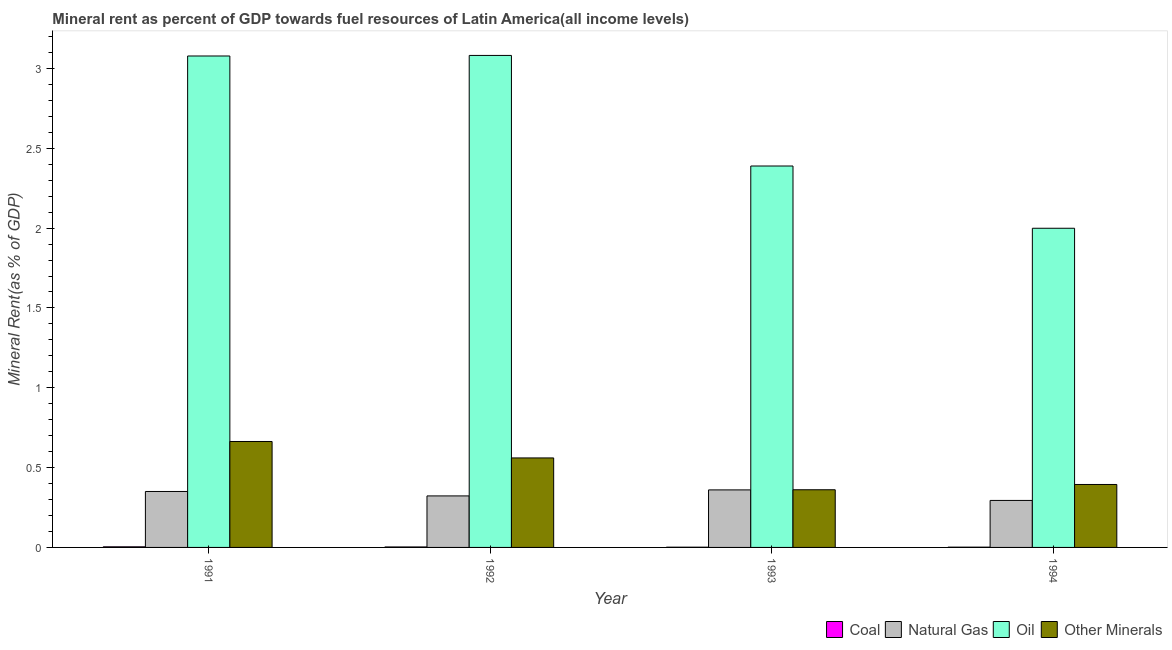How many different coloured bars are there?
Provide a short and direct response. 4. Are the number of bars per tick equal to the number of legend labels?
Offer a terse response. Yes. Are the number of bars on each tick of the X-axis equal?
Provide a succinct answer. Yes. How many bars are there on the 3rd tick from the left?
Your response must be concise. 4. What is the label of the 4th group of bars from the left?
Keep it short and to the point. 1994. In how many cases, is the number of bars for a given year not equal to the number of legend labels?
Your answer should be compact. 0. What is the natural gas rent in 1991?
Keep it short and to the point. 0.35. Across all years, what is the maximum  rent of other minerals?
Your response must be concise. 0.66. Across all years, what is the minimum natural gas rent?
Give a very brief answer. 0.29. In which year was the natural gas rent maximum?
Your answer should be very brief. 1993. What is the total natural gas rent in the graph?
Your response must be concise. 1.33. What is the difference between the  rent of other minerals in 1991 and that in 1993?
Your answer should be very brief. 0.3. What is the difference between the  rent of other minerals in 1991 and the natural gas rent in 1994?
Give a very brief answer. 0.27. What is the average  rent of other minerals per year?
Provide a short and direct response. 0.49. In the year 1992, what is the difference between the coal rent and natural gas rent?
Ensure brevity in your answer.  0. In how many years, is the  rent of other minerals greater than 3 %?
Give a very brief answer. 0. What is the ratio of the natural gas rent in 1992 to that in 1993?
Ensure brevity in your answer.  0.9. What is the difference between the highest and the second highest natural gas rent?
Keep it short and to the point. 0.01. What is the difference between the highest and the lowest natural gas rent?
Your response must be concise. 0.07. In how many years, is the  rent of other minerals greater than the average  rent of other minerals taken over all years?
Make the answer very short. 2. Is the sum of the coal rent in 1991 and 1992 greater than the maximum  rent of other minerals across all years?
Provide a succinct answer. Yes. Is it the case that in every year, the sum of the  rent of other minerals and oil rent is greater than the sum of coal rent and natural gas rent?
Give a very brief answer. Yes. What does the 4th bar from the left in 1991 represents?
Offer a terse response. Other Minerals. What does the 2nd bar from the right in 1993 represents?
Your answer should be very brief. Oil. Are all the bars in the graph horizontal?
Provide a succinct answer. No. Are the values on the major ticks of Y-axis written in scientific E-notation?
Your answer should be compact. No. Does the graph contain grids?
Your response must be concise. No. Where does the legend appear in the graph?
Your answer should be compact. Bottom right. How are the legend labels stacked?
Give a very brief answer. Horizontal. What is the title of the graph?
Your response must be concise. Mineral rent as percent of GDP towards fuel resources of Latin America(all income levels). What is the label or title of the Y-axis?
Provide a succinct answer. Mineral Rent(as % of GDP). What is the Mineral Rent(as % of GDP) in Coal in 1991?
Provide a short and direct response. 0. What is the Mineral Rent(as % of GDP) in Natural Gas in 1991?
Your answer should be very brief. 0.35. What is the Mineral Rent(as % of GDP) of Oil in 1991?
Offer a terse response. 3.08. What is the Mineral Rent(as % of GDP) of Other Minerals in 1991?
Offer a terse response. 0.66. What is the Mineral Rent(as % of GDP) in Coal in 1992?
Make the answer very short. 0. What is the Mineral Rent(as % of GDP) in Natural Gas in 1992?
Your answer should be compact. 0.32. What is the Mineral Rent(as % of GDP) of Oil in 1992?
Your answer should be compact. 3.08. What is the Mineral Rent(as % of GDP) in Other Minerals in 1992?
Your answer should be compact. 0.56. What is the Mineral Rent(as % of GDP) in Coal in 1993?
Offer a very short reply. 0. What is the Mineral Rent(as % of GDP) in Natural Gas in 1993?
Provide a short and direct response. 0.36. What is the Mineral Rent(as % of GDP) in Oil in 1993?
Your answer should be very brief. 2.39. What is the Mineral Rent(as % of GDP) in Other Minerals in 1993?
Provide a short and direct response. 0.36. What is the Mineral Rent(as % of GDP) in Coal in 1994?
Provide a short and direct response. 0. What is the Mineral Rent(as % of GDP) in Natural Gas in 1994?
Your answer should be very brief. 0.29. What is the Mineral Rent(as % of GDP) of Oil in 1994?
Keep it short and to the point. 2. What is the Mineral Rent(as % of GDP) in Other Minerals in 1994?
Keep it short and to the point. 0.39. Across all years, what is the maximum Mineral Rent(as % of GDP) of Coal?
Provide a succinct answer. 0. Across all years, what is the maximum Mineral Rent(as % of GDP) in Natural Gas?
Your answer should be compact. 0.36. Across all years, what is the maximum Mineral Rent(as % of GDP) in Oil?
Your answer should be very brief. 3.08. Across all years, what is the maximum Mineral Rent(as % of GDP) of Other Minerals?
Give a very brief answer. 0.66. Across all years, what is the minimum Mineral Rent(as % of GDP) in Coal?
Provide a short and direct response. 0. Across all years, what is the minimum Mineral Rent(as % of GDP) of Natural Gas?
Keep it short and to the point. 0.29. Across all years, what is the minimum Mineral Rent(as % of GDP) of Oil?
Your answer should be very brief. 2. Across all years, what is the minimum Mineral Rent(as % of GDP) of Other Minerals?
Give a very brief answer. 0.36. What is the total Mineral Rent(as % of GDP) in Coal in the graph?
Provide a short and direct response. 0.01. What is the total Mineral Rent(as % of GDP) of Natural Gas in the graph?
Make the answer very short. 1.33. What is the total Mineral Rent(as % of GDP) in Oil in the graph?
Offer a terse response. 10.55. What is the total Mineral Rent(as % of GDP) in Other Minerals in the graph?
Keep it short and to the point. 1.98. What is the difference between the Mineral Rent(as % of GDP) of Coal in 1991 and that in 1992?
Ensure brevity in your answer.  0. What is the difference between the Mineral Rent(as % of GDP) of Natural Gas in 1991 and that in 1992?
Provide a short and direct response. 0.03. What is the difference between the Mineral Rent(as % of GDP) in Oil in 1991 and that in 1992?
Your answer should be compact. -0. What is the difference between the Mineral Rent(as % of GDP) in Other Minerals in 1991 and that in 1992?
Offer a very short reply. 0.1. What is the difference between the Mineral Rent(as % of GDP) of Coal in 1991 and that in 1993?
Provide a short and direct response. 0. What is the difference between the Mineral Rent(as % of GDP) in Natural Gas in 1991 and that in 1993?
Offer a very short reply. -0.01. What is the difference between the Mineral Rent(as % of GDP) in Oil in 1991 and that in 1993?
Provide a succinct answer. 0.69. What is the difference between the Mineral Rent(as % of GDP) in Other Minerals in 1991 and that in 1993?
Offer a terse response. 0.3. What is the difference between the Mineral Rent(as % of GDP) in Coal in 1991 and that in 1994?
Offer a terse response. 0. What is the difference between the Mineral Rent(as % of GDP) in Natural Gas in 1991 and that in 1994?
Ensure brevity in your answer.  0.06. What is the difference between the Mineral Rent(as % of GDP) in Oil in 1991 and that in 1994?
Provide a short and direct response. 1.08. What is the difference between the Mineral Rent(as % of GDP) of Other Minerals in 1991 and that in 1994?
Make the answer very short. 0.27. What is the difference between the Mineral Rent(as % of GDP) in Coal in 1992 and that in 1993?
Offer a terse response. 0. What is the difference between the Mineral Rent(as % of GDP) of Natural Gas in 1992 and that in 1993?
Ensure brevity in your answer.  -0.04. What is the difference between the Mineral Rent(as % of GDP) of Oil in 1992 and that in 1993?
Keep it short and to the point. 0.69. What is the difference between the Mineral Rent(as % of GDP) in Other Minerals in 1992 and that in 1993?
Give a very brief answer. 0.2. What is the difference between the Mineral Rent(as % of GDP) of Coal in 1992 and that in 1994?
Offer a very short reply. 0. What is the difference between the Mineral Rent(as % of GDP) in Natural Gas in 1992 and that in 1994?
Offer a very short reply. 0.03. What is the difference between the Mineral Rent(as % of GDP) in Oil in 1992 and that in 1994?
Ensure brevity in your answer.  1.08. What is the difference between the Mineral Rent(as % of GDP) of Other Minerals in 1992 and that in 1994?
Keep it short and to the point. 0.17. What is the difference between the Mineral Rent(as % of GDP) of Coal in 1993 and that in 1994?
Your response must be concise. -0. What is the difference between the Mineral Rent(as % of GDP) of Natural Gas in 1993 and that in 1994?
Give a very brief answer. 0.07. What is the difference between the Mineral Rent(as % of GDP) of Oil in 1993 and that in 1994?
Provide a succinct answer. 0.39. What is the difference between the Mineral Rent(as % of GDP) of Other Minerals in 1993 and that in 1994?
Your response must be concise. -0.03. What is the difference between the Mineral Rent(as % of GDP) of Coal in 1991 and the Mineral Rent(as % of GDP) of Natural Gas in 1992?
Your answer should be very brief. -0.32. What is the difference between the Mineral Rent(as % of GDP) in Coal in 1991 and the Mineral Rent(as % of GDP) in Oil in 1992?
Provide a succinct answer. -3.08. What is the difference between the Mineral Rent(as % of GDP) in Coal in 1991 and the Mineral Rent(as % of GDP) in Other Minerals in 1992?
Ensure brevity in your answer.  -0.56. What is the difference between the Mineral Rent(as % of GDP) of Natural Gas in 1991 and the Mineral Rent(as % of GDP) of Oil in 1992?
Provide a succinct answer. -2.73. What is the difference between the Mineral Rent(as % of GDP) of Natural Gas in 1991 and the Mineral Rent(as % of GDP) of Other Minerals in 1992?
Ensure brevity in your answer.  -0.21. What is the difference between the Mineral Rent(as % of GDP) of Oil in 1991 and the Mineral Rent(as % of GDP) of Other Minerals in 1992?
Give a very brief answer. 2.52. What is the difference between the Mineral Rent(as % of GDP) of Coal in 1991 and the Mineral Rent(as % of GDP) of Natural Gas in 1993?
Your answer should be compact. -0.36. What is the difference between the Mineral Rent(as % of GDP) of Coal in 1991 and the Mineral Rent(as % of GDP) of Oil in 1993?
Your answer should be very brief. -2.39. What is the difference between the Mineral Rent(as % of GDP) in Coal in 1991 and the Mineral Rent(as % of GDP) in Other Minerals in 1993?
Provide a succinct answer. -0.36. What is the difference between the Mineral Rent(as % of GDP) in Natural Gas in 1991 and the Mineral Rent(as % of GDP) in Oil in 1993?
Your answer should be very brief. -2.04. What is the difference between the Mineral Rent(as % of GDP) of Natural Gas in 1991 and the Mineral Rent(as % of GDP) of Other Minerals in 1993?
Your response must be concise. -0.01. What is the difference between the Mineral Rent(as % of GDP) of Oil in 1991 and the Mineral Rent(as % of GDP) of Other Minerals in 1993?
Ensure brevity in your answer.  2.72. What is the difference between the Mineral Rent(as % of GDP) in Coal in 1991 and the Mineral Rent(as % of GDP) in Natural Gas in 1994?
Your response must be concise. -0.29. What is the difference between the Mineral Rent(as % of GDP) in Coal in 1991 and the Mineral Rent(as % of GDP) in Oil in 1994?
Provide a succinct answer. -2. What is the difference between the Mineral Rent(as % of GDP) in Coal in 1991 and the Mineral Rent(as % of GDP) in Other Minerals in 1994?
Keep it short and to the point. -0.39. What is the difference between the Mineral Rent(as % of GDP) in Natural Gas in 1991 and the Mineral Rent(as % of GDP) in Oil in 1994?
Offer a very short reply. -1.65. What is the difference between the Mineral Rent(as % of GDP) of Natural Gas in 1991 and the Mineral Rent(as % of GDP) of Other Minerals in 1994?
Your response must be concise. -0.04. What is the difference between the Mineral Rent(as % of GDP) of Oil in 1991 and the Mineral Rent(as % of GDP) of Other Minerals in 1994?
Offer a very short reply. 2.68. What is the difference between the Mineral Rent(as % of GDP) of Coal in 1992 and the Mineral Rent(as % of GDP) of Natural Gas in 1993?
Offer a very short reply. -0.36. What is the difference between the Mineral Rent(as % of GDP) of Coal in 1992 and the Mineral Rent(as % of GDP) of Oil in 1993?
Provide a succinct answer. -2.39. What is the difference between the Mineral Rent(as % of GDP) in Coal in 1992 and the Mineral Rent(as % of GDP) in Other Minerals in 1993?
Make the answer very short. -0.36. What is the difference between the Mineral Rent(as % of GDP) of Natural Gas in 1992 and the Mineral Rent(as % of GDP) of Oil in 1993?
Keep it short and to the point. -2.07. What is the difference between the Mineral Rent(as % of GDP) in Natural Gas in 1992 and the Mineral Rent(as % of GDP) in Other Minerals in 1993?
Keep it short and to the point. -0.04. What is the difference between the Mineral Rent(as % of GDP) of Oil in 1992 and the Mineral Rent(as % of GDP) of Other Minerals in 1993?
Ensure brevity in your answer.  2.72. What is the difference between the Mineral Rent(as % of GDP) of Coal in 1992 and the Mineral Rent(as % of GDP) of Natural Gas in 1994?
Your response must be concise. -0.29. What is the difference between the Mineral Rent(as % of GDP) of Coal in 1992 and the Mineral Rent(as % of GDP) of Oil in 1994?
Provide a short and direct response. -2. What is the difference between the Mineral Rent(as % of GDP) in Coal in 1992 and the Mineral Rent(as % of GDP) in Other Minerals in 1994?
Offer a very short reply. -0.39. What is the difference between the Mineral Rent(as % of GDP) in Natural Gas in 1992 and the Mineral Rent(as % of GDP) in Oil in 1994?
Make the answer very short. -1.68. What is the difference between the Mineral Rent(as % of GDP) in Natural Gas in 1992 and the Mineral Rent(as % of GDP) in Other Minerals in 1994?
Provide a short and direct response. -0.07. What is the difference between the Mineral Rent(as % of GDP) in Oil in 1992 and the Mineral Rent(as % of GDP) in Other Minerals in 1994?
Provide a succinct answer. 2.69. What is the difference between the Mineral Rent(as % of GDP) of Coal in 1993 and the Mineral Rent(as % of GDP) of Natural Gas in 1994?
Provide a short and direct response. -0.29. What is the difference between the Mineral Rent(as % of GDP) in Coal in 1993 and the Mineral Rent(as % of GDP) in Oil in 1994?
Give a very brief answer. -2. What is the difference between the Mineral Rent(as % of GDP) in Coal in 1993 and the Mineral Rent(as % of GDP) in Other Minerals in 1994?
Provide a succinct answer. -0.39. What is the difference between the Mineral Rent(as % of GDP) of Natural Gas in 1993 and the Mineral Rent(as % of GDP) of Oil in 1994?
Keep it short and to the point. -1.64. What is the difference between the Mineral Rent(as % of GDP) in Natural Gas in 1993 and the Mineral Rent(as % of GDP) in Other Minerals in 1994?
Ensure brevity in your answer.  -0.03. What is the difference between the Mineral Rent(as % of GDP) in Oil in 1993 and the Mineral Rent(as % of GDP) in Other Minerals in 1994?
Give a very brief answer. 1.99. What is the average Mineral Rent(as % of GDP) in Coal per year?
Make the answer very short. 0. What is the average Mineral Rent(as % of GDP) in Natural Gas per year?
Make the answer very short. 0.33. What is the average Mineral Rent(as % of GDP) of Oil per year?
Make the answer very short. 2.64. What is the average Mineral Rent(as % of GDP) of Other Minerals per year?
Offer a terse response. 0.49. In the year 1991, what is the difference between the Mineral Rent(as % of GDP) of Coal and Mineral Rent(as % of GDP) of Natural Gas?
Ensure brevity in your answer.  -0.35. In the year 1991, what is the difference between the Mineral Rent(as % of GDP) of Coal and Mineral Rent(as % of GDP) of Oil?
Your answer should be compact. -3.07. In the year 1991, what is the difference between the Mineral Rent(as % of GDP) in Coal and Mineral Rent(as % of GDP) in Other Minerals?
Offer a very short reply. -0.66. In the year 1991, what is the difference between the Mineral Rent(as % of GDP) of Natural Gas and Mineral Rent(as % of GDP) of Oil?
Offer a terse response. -2.73. In the year 1991, what is the difference between the Mineral Rent(as % of GDP) in Natural Gas and Mineral Rent(as % of GDP) in Other Minerals?
Make the answer very short. -0.31. In the year 1991, what is the difference between the Mineral Rent(as % of GDP) of Oil and Mineral Rent(as % of GDP) of Other Minerals?
Your response must be concise. 2.41. In the year 1992, what is the difference between the Mineral Rent(as % of GDP) of Coal and Mineral Rent(as % of GDP) of Natural Gas?
Offer a terse response. -0.32. In the year 1992, what is the difference between the Mineral Rent(as % of GDP) of Coal and Mineral Rent(as % of GDP) of Oil?
Keep it short and to the point. -3.08. In the year 1992, what is the difference between the Mineral Rent(as % of GDP) in Coal and Mineral Rent(as % of GDP) in Other Minerals?
Your answer should be compact. -0.56. In the year 1992, what is the difference between the Mineral Rent(as % of GDP) in Natural Gas and Mineral Rent(as % of GDP) in Oil?
Make the answer very short. -2.76. In the year 1992, what is the difference between the Mineral Rent(as % of GDP) of Natural Gas and Mineral Rent(as % of GDP) of Other Minerals?
Your answer should be very brief. -0.24. In the year 1992, what is the difference between the Mineral Rent(as % of GDP) in Oil and Mineral Rent(as % of GDP) in Other Minerals?
Provide a succinct answer. 2.52. In the year 1993, what is the difference between the Mineral Rent(as % of GDP) of Coal and Mineral Rent(as % of GDP) of Natural Gas?
Keep it short and to the point. -0.36. In the year 1993, what is the difference between the Mineral Rent(as % of GDP) of Coal and Mineral Rent(as % of GDP) of Oil?
Provide a short and direct response. -2.39. In the year 1993, what is the difference between the Mineral Rent(as % of GDP) in Coal and Mineral Rent(as % of GDP) in Other Minerals?
Offer a terse response. -0.36. In the year 1993, what is the difference between the Mineral Rent(as % of GDP) in Natural Gas and Mineral Rent(as % of GDP) in Oil?
Your response must be concise. -2.03. In the year 1993, what is the difference between the Mineral Rent(as % of GDP) in Natural Gas and Mineral Rent(as % of GDP) in Other Minerals?
Offer a terse response. -0. In the year 1993, what is the difference between the Mineral Rent(as % of GDP) of Oil and Mineral Rent(as % of GDP) of Other Minerals?
Offer a terse response. 2.03. In the year 1994, what is the difference between the Mineral Rent(as % of GDP) of Coal and Mineral Rent(as % of GDP) of Natural Gas?
Give a very brief answer. -0.29. In the year 1994, what is the difference between the Mineral Rent(as % of GDP) of Coal and Mineral Rent(as % of GDP) of Oil?
Ensure brevity in your answer.  -2. In the year 1994, what is the difference between the Mineral Rent(as % of GDP) in Coal and Mineral Rent(as % of GDP) in Other Minerals?
Keep it short and to the point. -0.39. In the year 1994, what is the difference between the Mineral Rent(as % of GDP) in Natural Gas and Mineral Rent(as % of GDP) in Oil?
Make the answer very short. -1.7. In the year 1994, what is the difference between the Mineral Rent(as % of GDP) in Natural Gas and Mineral Rent(as % of GDP) in Other Minerals?
Offer a terse response. -0.1. In the year 1994, what is the difference between the Mineral Rent(as % of GDP) in Oil and Mineral Rent(as % of GDP) in Other Minerals?
Make the answer very short. 1.6. What is the ratio of the Mineral Rent(as % of GDP) of Coal in 1991 to that in 1992?
Give a very brief answer. 1.29. What is the ratio of the Mineral Rent(as % of GDP) in Natural Gas in 1991 to that in 1992?
Offer a terse response. 1.09. What is the ratio of the Mineral Rent(as % of GDP) of Oil in 1991 to that in 1992?
Your answer should be compact. 1. What is the ratio of the Mineral Rent(as % of GDP) in Other Minerals in 1991 to that in 1992?
Give a very brief answer. 1.18. What is the ratio of the Mineral Rent(as % of GDP) in Coal in 1991 to that in 1993?
Provide a succinct answer. 2.55. What is the ratio of the Mineral Rent(as % of GDP) of Natural Gas in 1991 to that in 1993?
Offer a terse response. 0.97. What is the ratio of the Mineral Rent(as % of GDP) of Oil in 1991 to that in 1993?
Make the answer very short. 1.29. What is the ratio of the Mineral Rent(as % of GDP) in Other Minerals in 1991 to that in 1993?
Ensure brevity in your answer.  1.84. What is the ratio of the Mineral Rent(as % of GDP) in Coal in 1991 to that in 1994?
Offer a very short reply. 2.34. What is the ratio of the Mineral Rent(as % of GDP) of Natural Gas in 1991 to that in 1994?
Offer a terse response. 1.19. What is the ratio of the Mineral Rent(as % of GDP) in Oil in 1991 to that in 1994?
Give a very brief answer. 1.54. What is the ratio of the Mineral Rent(as % of GDP) in Other Minerals in 1991 to that in 1994?
Make the answer very short. 1.68. What is the ratio of the Mineral Rent(as % of GDP) in Coal in 1992 to that in 1993?
Offer a terse response. 1.98. What is the ratio of the Mineral Rent(as % of GDP) of Natural Gas in 1992 to that in 1993?
Your answer should be compact. 0.9. What is the ratio of the Mineral Rent(as % of GDP) in Oil in 1992 to that in 1993?
Ensure brevity in your answer.  1.29. What is the ratio of the Mineral Rent(as % of GDP) in Other Minerals in 1992 to that in 1993?
Your answer should be very brief. 1.55. What is the ratio of the Mineral Rent(as % of GDP) in Coal in 1992 to that in 1994?
Offer a terse response. 1.81. What is the ratio of the Mineral Rent(as % of GDP) in Natural Gas in 1992 to that in 1994?
Make the answer very short. 1.1. What is the ratio of the Mineral Rent(as % of GDP) in Oil in 1992 to that in 1994?
Provide a short and direct response. 1.54. What is the ratio of the Mineral Rent(as % of GDP) of Other Minerals in 1992 to that in 1994?
Your response must be concise. 1.42. What is the ratio of the Mineral Rent(as % of GDP) in Coal in 1993 to that in 1994?
Your answer should be very brief. 0.92. What is the ratio of the Mineral Rent(as % of GDP) of Natural Gas in 1993 to that in 1994?
Ensure brevity in your answer.  1.22. What is the ratio of the Mineral Rent(as % of GDP) of Oil in 1993 to that in 1994?
Offer a terse response. 1.2. What is the ratio of the Mineral Rent(as % of GDP) of Other Minerals in 1993 to that in 1994?
Keep it short and to the point. 0.92. What is the difference between the highest and the second highest Mineral Rent(as % of GDP) of Coal?
Make the answer very short. 0. What is the difference between the highest and the second highest Mineral Rent(as % of GDP) in Natural Gas?
Offer a very short reply. 0.01. What is the difference between the highest and the second highest Mineral Rent(as % of GDP) in Oil?
Your response must be concise. 0. What is the difference between the highest and the second highest Mineral Rent(as % of GDP) in Other Minerals?
Provide a succinct answer. 0.1. What is the difference between the highest and the lowest Mineral Rent(as % of GDP) in Coal?
Offer a terse response. 0. What is the difference between the highest and the lowest Mineral Rent(as % of GDP) in Natural Gas?
Provide a short and direct response. 0.07. What is the difference between the highest and the lowest Mineral Rent(as % of GDP) of Oil?
Offer a terse response. 1.08. What is the difference between the highest and the lowest Mineral Rent(as % of GDP) in Other Minerals?
Ensure brevity in your answer.  0.3. 